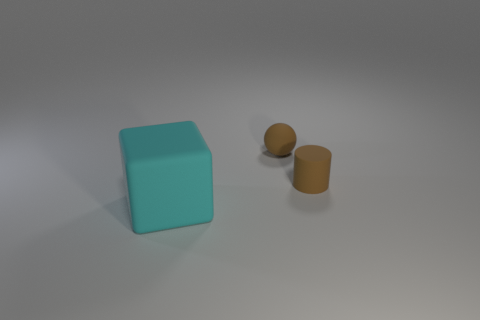What number of other objects are there of the same material as the big cyan cube?
Make the answer very short. 2. There is a large cyan rubber block; what number of matte things are behind it?
Your answer should be compact. 2. How many cubes are either tiny objects or big cyan things?
Ensure brevity in your answer.  1. How big is the object that is in front of the tiny sphere and on the left side of the matte cylinder?
Offer a very short reply. Large. What number of other things are there of the same color as the large object?
Provide a short and direct response. 0. Do the big cyan thing and the object on the right side of the brown sphere have the same material?
Provide a succinct answer. Yes. What number of things are objects that are on the right side of the cyan matte block or tiny brown objects?
Your answer should be very brief. 2. There is a matte object that is behind the block and in front of the ball; what is its shape?
Provide a short and direct response. Cylinder. Are there any other things that are the same size as the cyan matte block?
Your response must be concise. No. There is a cube that is made of the same material as the sphere; what size is it?
Provide a succinct answer. Large. 